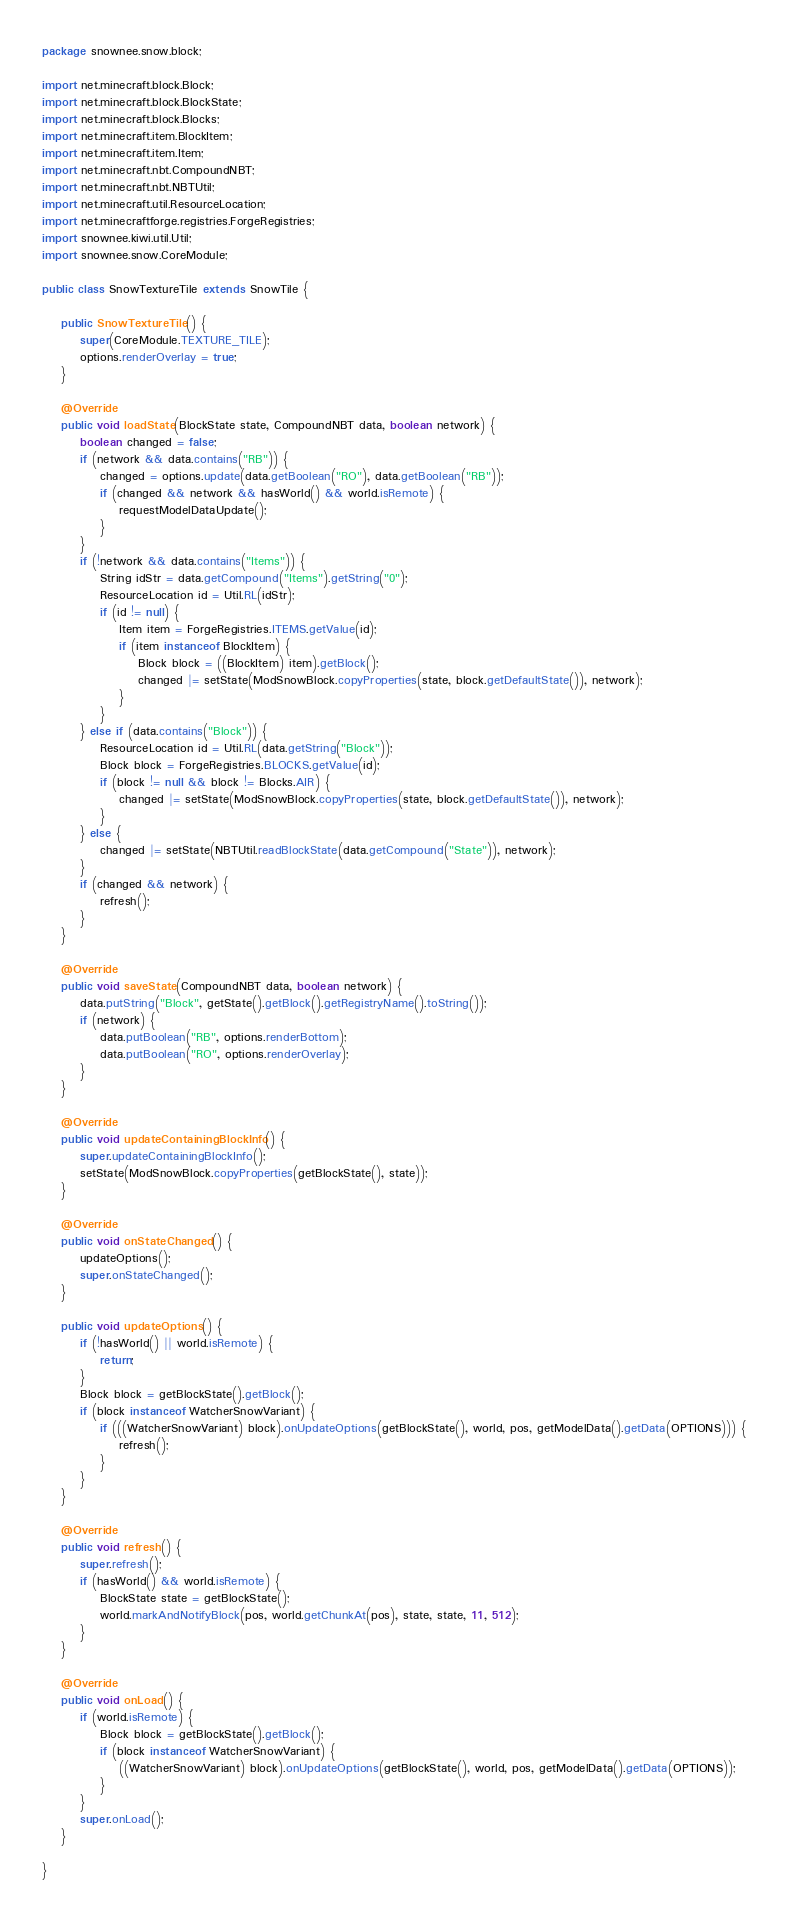Convert code to text. <code><loc_0><loc_0><loc_500><loc_500><_Java_>package snownee.snow.block;

import net.minecraft.block.Block;
import net.minecraft.block.BlockState;
import net.minecraft.block.Blocks;
import net.minecraft.item.BlockItem;
import net.minecraft.item.Item;
import net.minecraft.nbt.CompoundNBT;
import net.minecraft.nbt.NBTUtil;
import net.minecraft.util.ResourceLocation;
import net.minecraftforge.registries.ForgeRegistries;
import snownee.kiwi.util.Util;
import snownee.snow.CoreModule;

public class SnowTextureTile extends SnowTile {

	public SnowTextureTile() {
		super(CoreModule.TEXTURE_TILE);
		options.renderOverlay = true;
	}

	@Override
	public void loadState(BlockState state, CompoundNBT data, boolean network) {
		boolean changed = false;
		if (network && data.contains("RB")) {
			changed = options.update(data.getBoolean("RO"), data.getBoolean("RB"));
			if (changed && network && hasWorld() && world.isRemote) {
				requestModelDataUpdate();
			}
		}
		if (!network && data.contains("Items")) {
			String idStr = data.getCompound("Items").getString("0");
			ResourceLocation id = Util.RL(idStr);
			if (id != null) {
				Item item = ForgeRegistries.ITEMS.getValue(id);
				if (item instanceof BlockItem) {
					Block block = ((BlockItem) item).getBlock();
					changed |= setState(ModSnowBlock.copyProperties(state, block.getDefaultState()), network);
				}
			}
		} else if (data.contains("Block")) {
			ResourceLocation id = Util.RL(data.getString("Block"));
			Block block = ForgeRegistries.BLOCKS.getValue(id);
			if (block != null && block != Blocks.AIR) {
				changed |= setState(ModSnowBlock.copyProperties(state, block.getDefaultState()), network);
			}
		} else {
			changed |= setState(NBTUtil.readBlockState(data.getCompound("State")), network);
		}
		if (changed && network) {
			refresh();
		}
	}

	@Override
	public void saveState(CompoundNBT data, boolean network) {
		data.putString("Block", getState().getBlock().getRegistryName().toString());
		if (network) {
			data.putBoolean("RB", options.renderBottom);
			data.putBoolean("RO", options.renderOverlay);
		}
	}

	@Override
	public void updateContainingBlockInfo() {
		super.updateContainingBlockInfo();
		setState(ModSnowBlock.copyProperties(getBlockState(), state));
	}

	@Override
	public void onStateChanged() {
		updateOptions();
		super.onStateChanged();
	}

	public void updateOptions() {
		if (!hasWorld() || world.isRemote) {
			return;
		}
		Block block = getBlockState().getBlock();
		if (block instanceof WatcherSnowVariant) {
			if (((WatcherSnowVariant) block).onUpdateOptions(getBlockState(), world, pos, getModelData().getData(OPTIONS))) {
				refresh();
			}
		}
	}

	@Override
	public void refresh() {
		super.refresh();
		if (hasWorld() && world.isRemote) {
			BlockState state = getBlockState();
			world.markAndNotifyBlock(pos, world.getChunkAt(pos), state, state, 11, 512);
		}
	}

	@Override
	public void onLoad() {
		if (world.isRemote) {
			Block block = getBlockState().getBlock();
			if (block instanceof WatcherSnowVariant) {
				((WatcherSnowVariant) block).onUpdateOptions(getBlockState(), world, pos, getModelData().getData(OPTIONS));
			}
		}
		super.onLoad();
	}

}
</code> 